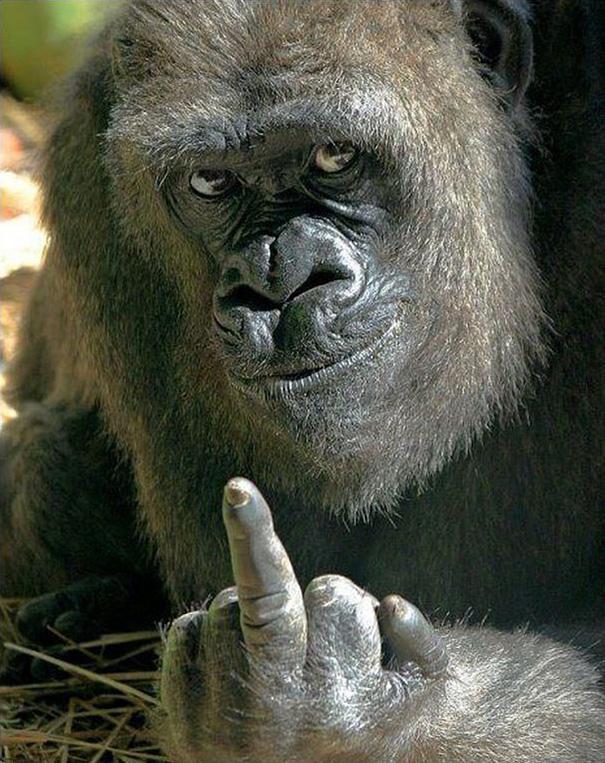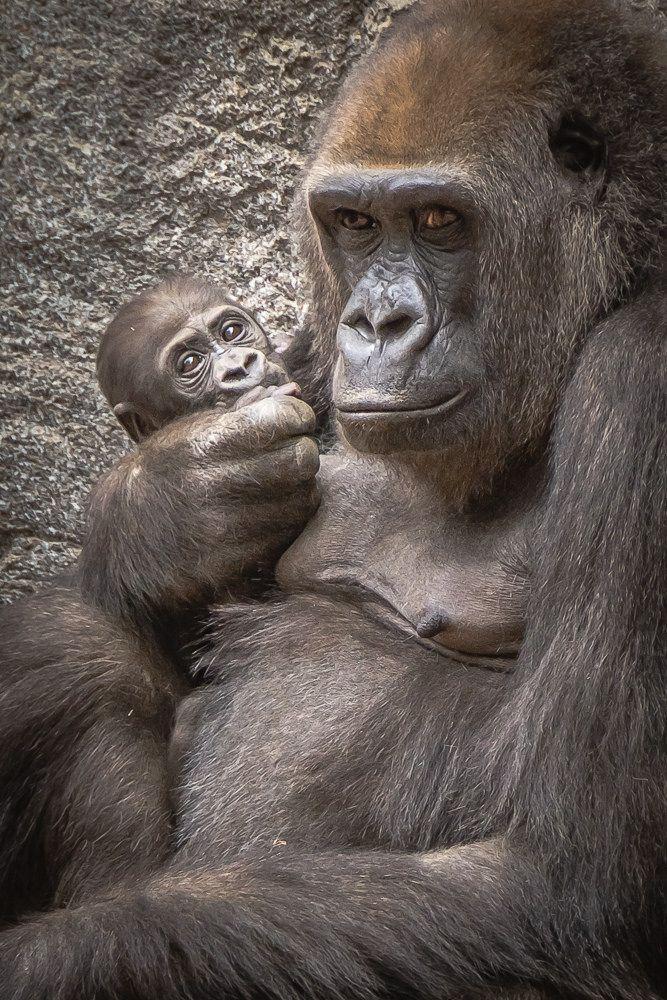The first image is the image on the left, the second image is the image on the right. Examine the images to the left and right. Is the description "In at least one image there are two gorilla one adult holding a single baby." accurate? Answer yes or no. Yes. The first image is the image on the left, the second image is the image on the right. Evaluate the accuracy of this statement regarding the images: "One image shows an adult gorilla cradling a baby gorilla at its chest with at least one arm.". Is it true? Answer yes or no. Yes. 